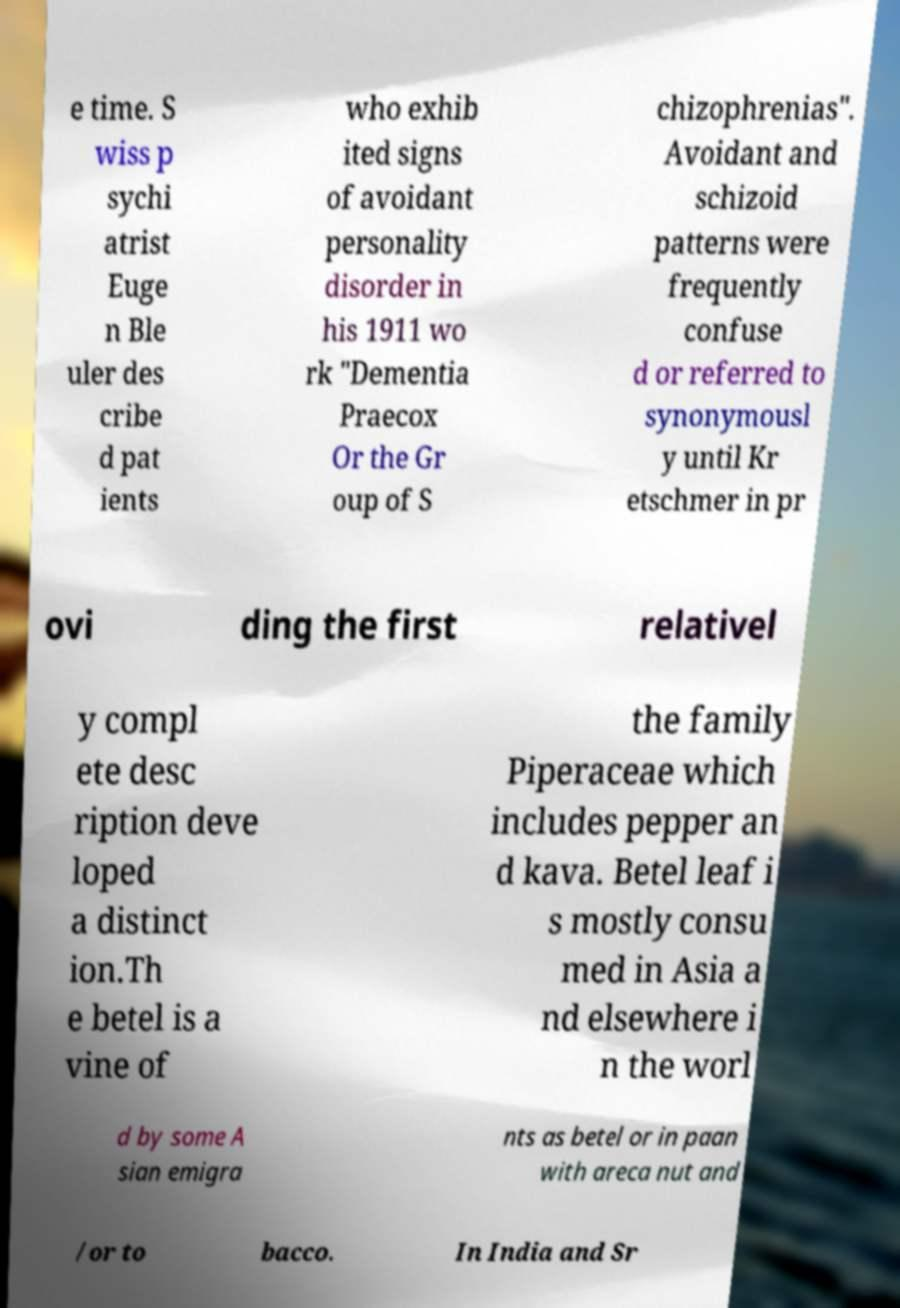Can you read and provide the text displayed in the image?This photo seems to have some interesting text. Can you extract and type it out for me? e time. S wiss p sychi atrist Euge n Ble uler des cribe d pat ients who exhib ited signs of avoidant personality disorder in his 1911 wo rk "Dementia Praecox Or the Gr oup of S chizophrenias". Avoidant and schizoid patterns were frequently confuse d or referred to synonymousl y until Kr etschmer in pr ovi ding the first relativel y compl ete desc ription deve loped a distinct ion.Th e betel is a vine of the family Piperaceae which includes pepper an d kava. Betel leaf i s mostly consu med in Asia a nd elsewhere i n the worl d by some A sian emigra nts as betel or in paan with areca nut and /or to bacco. In India and Sr 